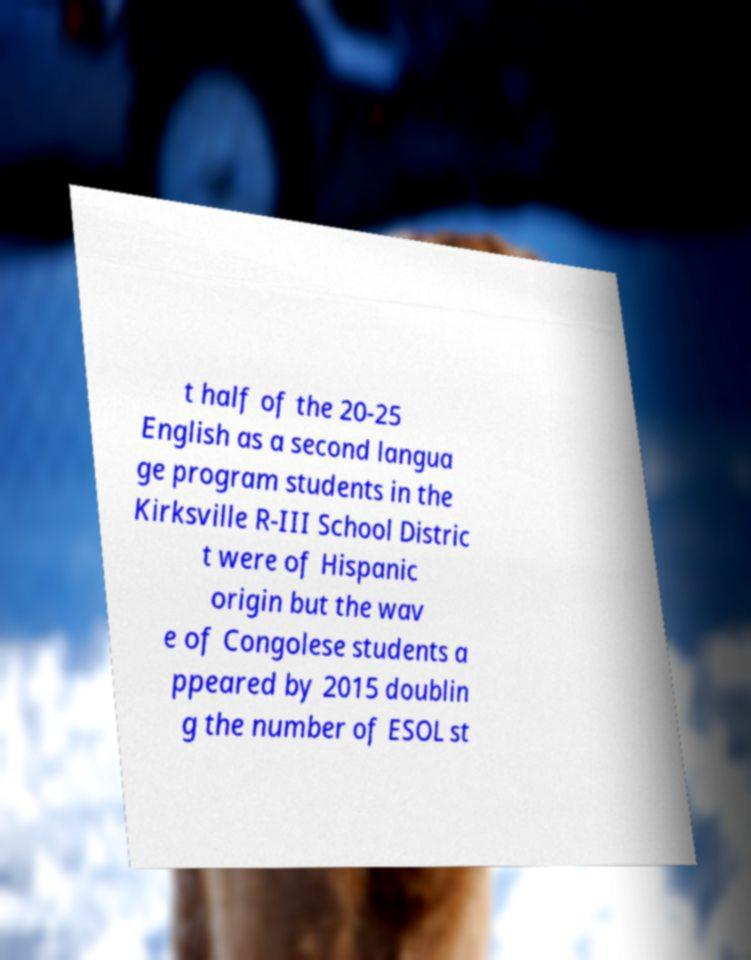Can you read and provide the text displayed in the image?This photo seems to have some interesting text. Can you extract and type it out for me? t half of the 20-25 English as a second langua ge program students in the Kirksville R-III School Distric t were of Hispanic origin but the wav e of Congolese students a ppeared by 2015 doublin g the number of ESOL st 